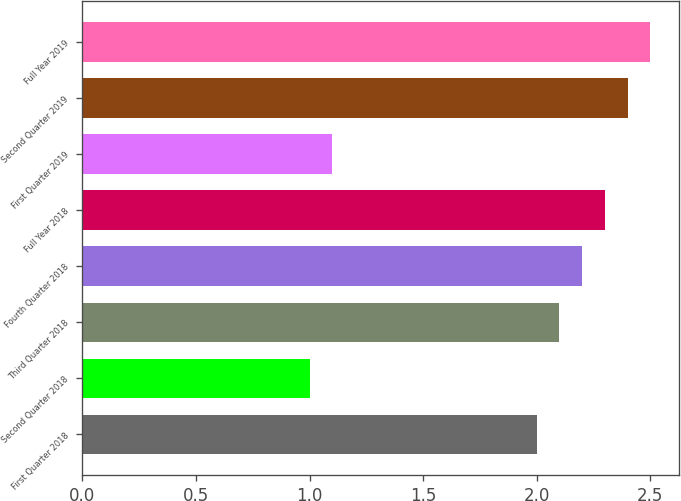Convert chart to OTSL. <chart><loc_0><loc_0><loc_500><loc_500><bar_chart><fcel>First Quarter 2018<fcel>Second Quarter 2018<fcel>Third Quarter 2018<fcel>Fourth Quarter 2018<fcel>Full Year 2018<fcel>First Quarter 2019<fcel>Second Quarter 2019<fcel>Full Year 2019<nl><fcel>2<fcel>1<fcel>2.1<fcel>2.2<fcel>2.3<fcel>1.1<fcel>2.4<fcel>2.5<nl></chart> 